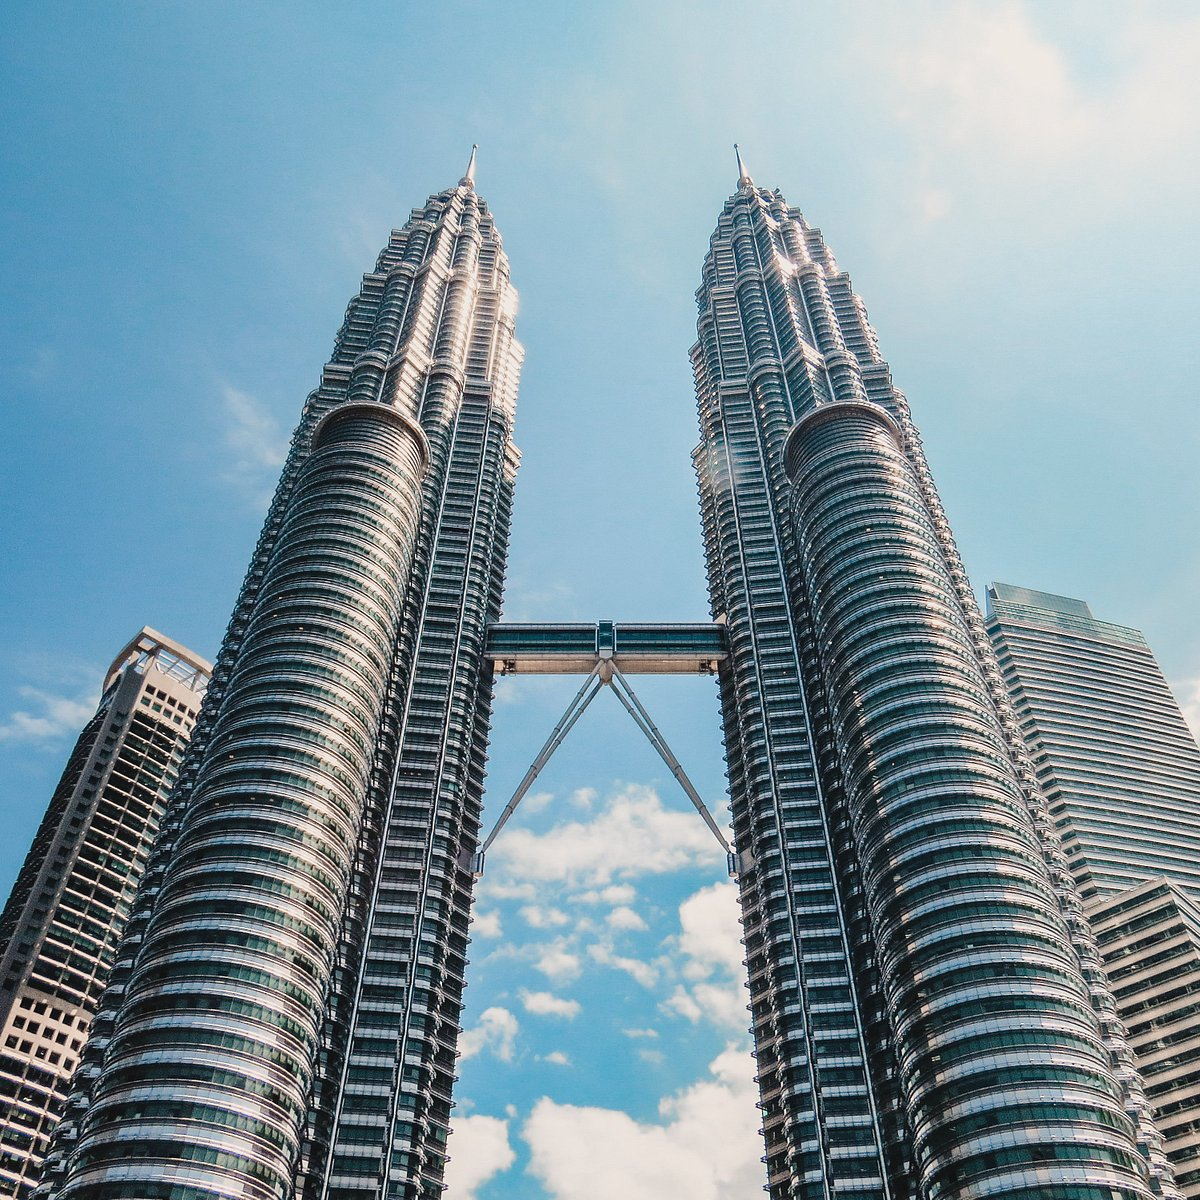Write a detailed description of the given image. The image showcases the iconic Petronas Twin Towers of Kuala Lumpur, Malaysia. These towers, primarily built from steel and glass, stand as a testament to modern architectural ambition. Captured from a low angle, the photo emphasizes the sheer scale of the buildings which stretch impressively into a clear blue sky dotted with light clouds. The skybridge, prominently visible, connects the two structures at the 41st and 42nd floors, serving both a functional and an aesthetic purpose. The design reflects a blend of technological advancement and artistic elegance, symbolizing Malaysia's growth and modernization. 